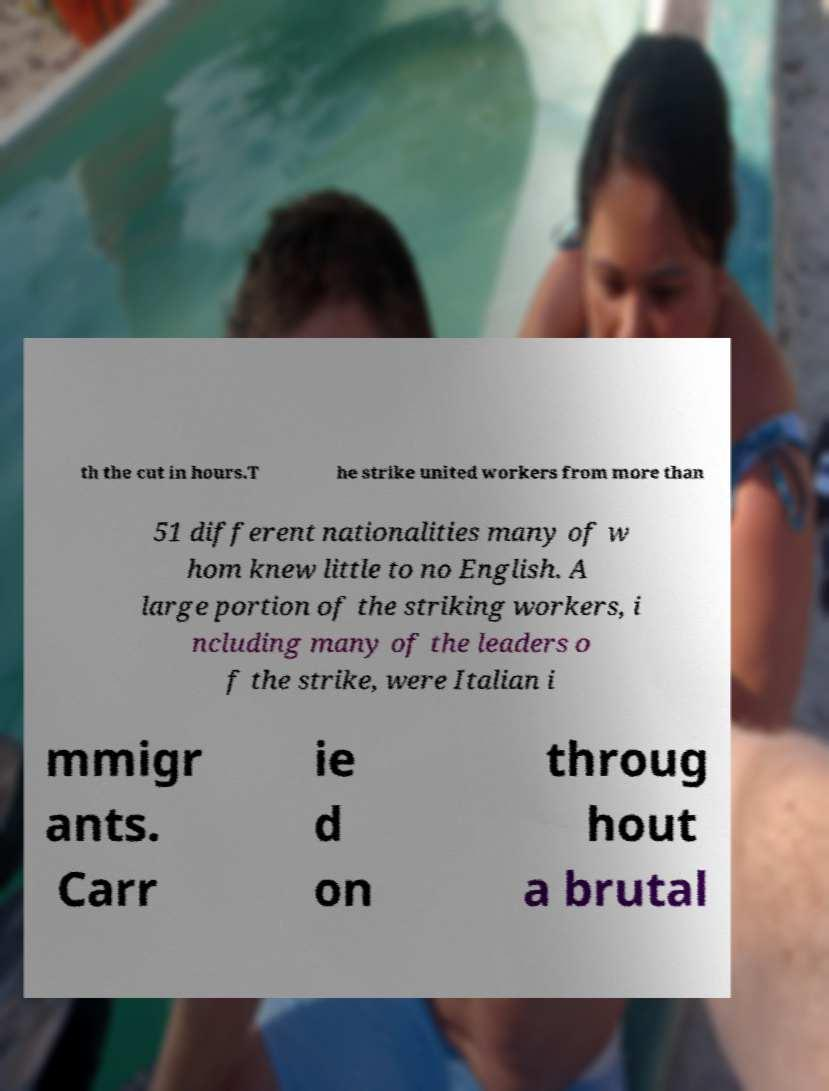For documentation purposes, I need the text within this image transcribed. Could you provide that? th the cut in hours.T he strike united workers from more than 51 different nationalities many of w hom knew little to no English. A large portion of the striking workers, i ncluding many of the leaders o f the strike, were Italian i mmigr ants. Carr ie d on throug hout a brutal 